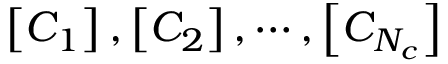Convert formula to latex. <formula><loc_0><loc_0><loc_500><loc_500>\left [ C _ { 1 } \right ] , \left [ C _ { 2 } \right ] , \cdots , \left [ C _ { N _ { c } } \right ]</formula> 